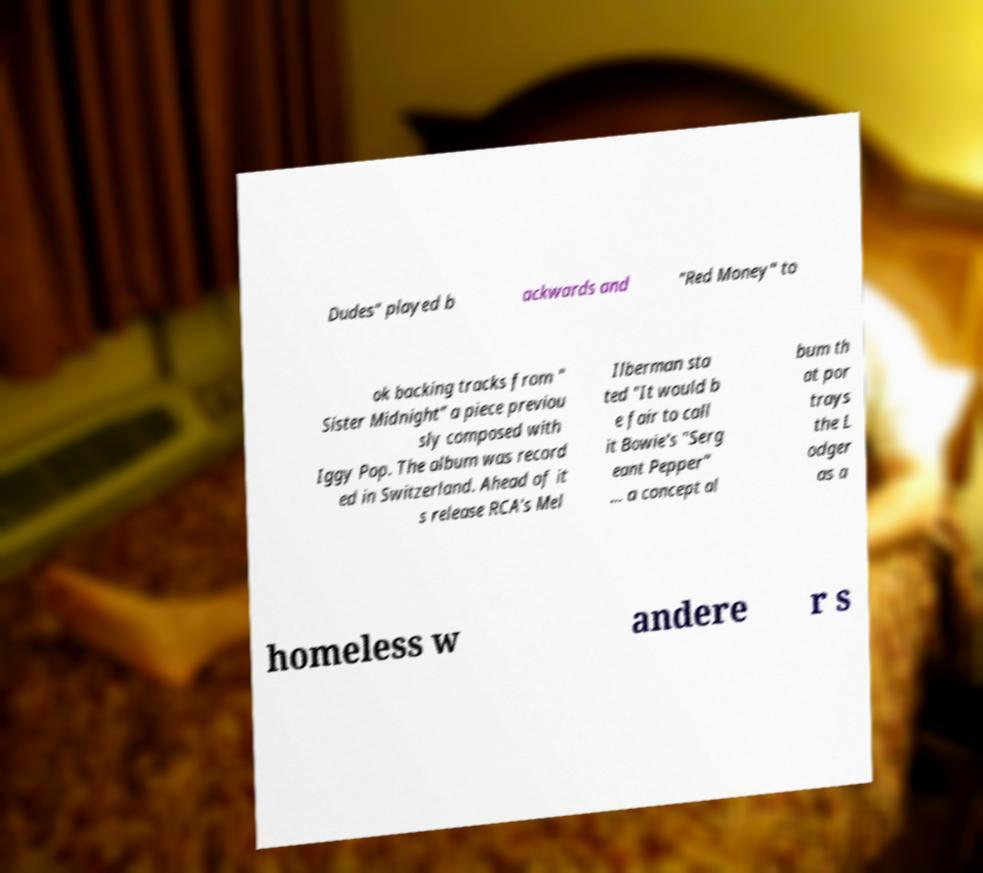There's text embedded in this image that I need extracted. Can you transcribe it verbatim? Dudes" played b ackwards and "Red Money" to ok backing tracks from " Sister Midnight" a piece previou sly composed with Iggy Pop. The album was record ed in Switzerland. Ahead of it s release RCA's Mel Ilberman sta ted "It would b e fair to call it Bowie's "Serg eant Pepper" ... a concept al bum th at por trays the L odger as a homeless w andere r s 